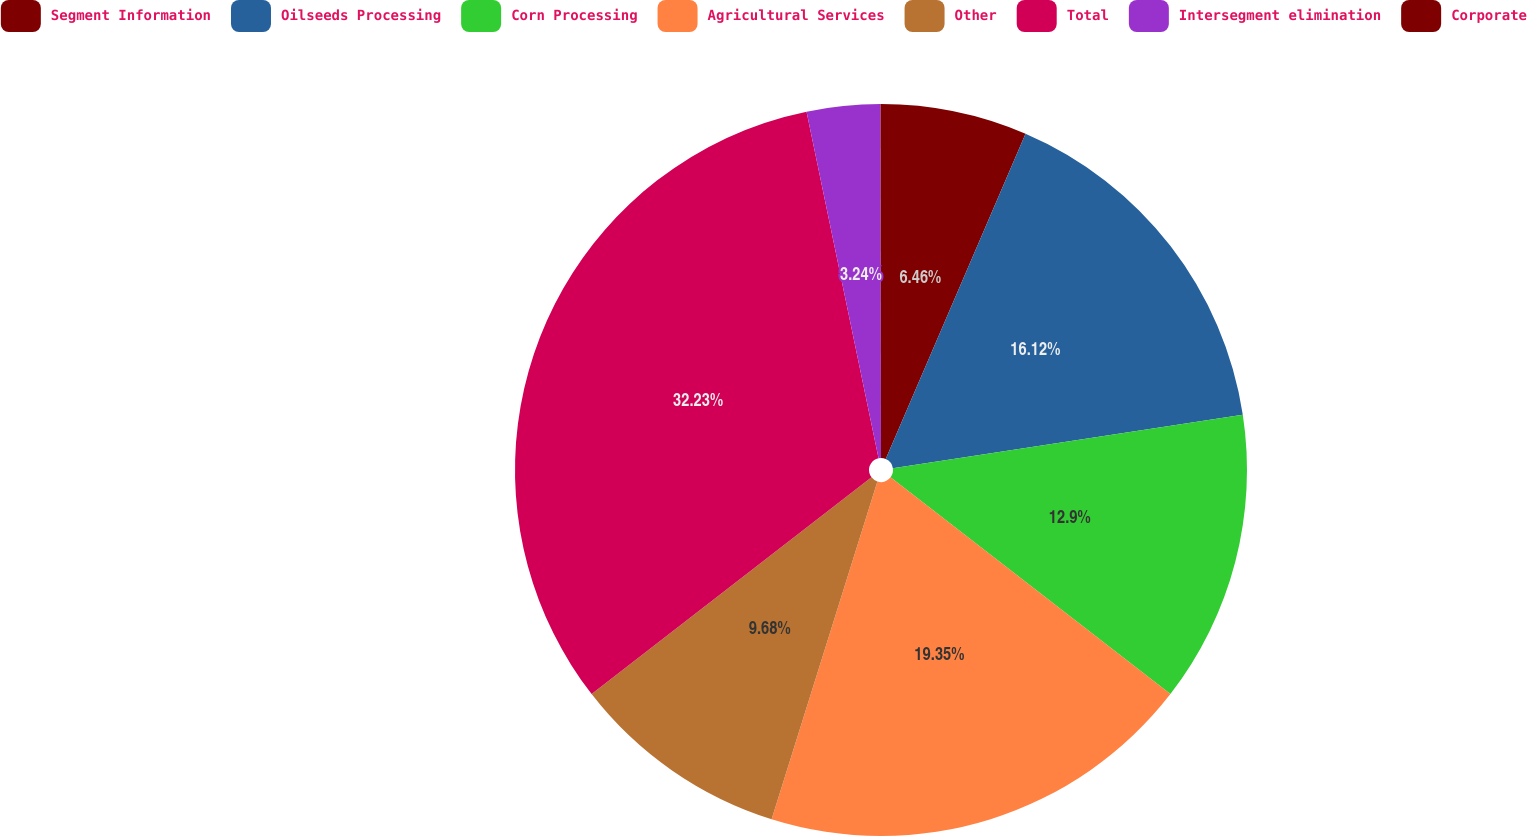Convert chart to OTSL. <chart><loc_0><loc_0><loc_500><loc_500><pie_chart><fcel>Segment Information<fcel>Oilseeds Processing<fcel>Corn Processing<fcel>Agricultural Services<fcel>Other<fcel>Total<fcel>Intersegment elimination<fcel>Corporate<nl><fcel>6.46%<fcel>16.12%<fcel>12.9%<fcel>19.34%<fcel>9.68%<fcel>32.22%<fcel>3.24%<fcel>0.02%<nl></chart> 